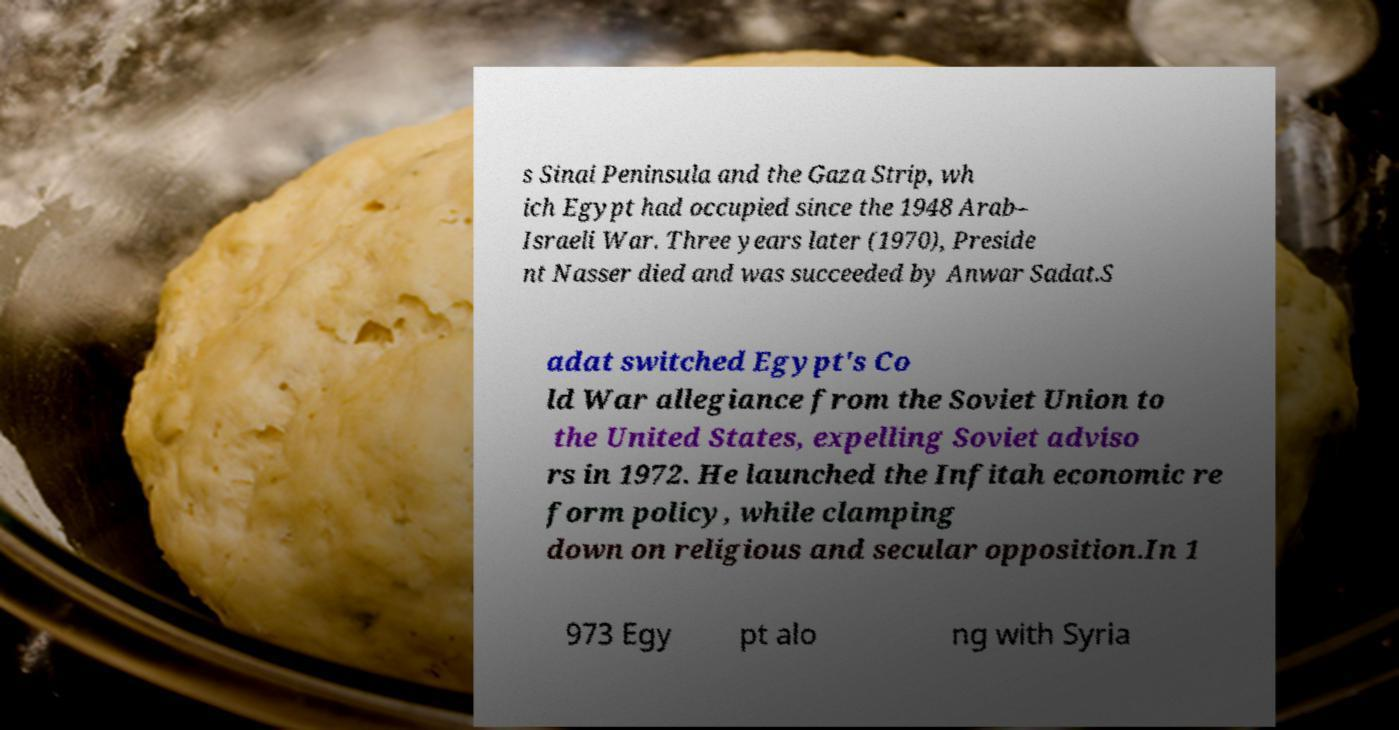I need the written content from this picture converted into text. Can you do that? s Sinai Peninsula and the Gaza Strip, wh ich Egypt had occupied since the 1948 Arab– Israeli War. Three years later (1970), Preside nt Nasser died and was succeeded by Anwar Sadat.S adat switched Egypt's Co ld War allegiance from the Soviet Union to the United States, expelling Soviet adviso rs in 1972. He launched the Infitah economic re form policy, while clamping down on religious and secular opposition.In 1 973 Egy pt alo ng with Syria 